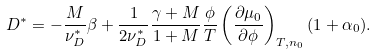Convert formula to latex. <formula><loc_0><loc_0><loc_500><loc_500>D ^ { * } = - \frac { M } { \nu _ { D } ^ { * } } \beta + \frac { 1 } { 2 \nu _ { D } ^ { * } } \frac { \gamma + M } { 1 + M } \frac { \phi } { T } \left ( \frac { \partial \mu _ { 0 } } { \partial \phi } \right ) _ { T , n _ { 0 } } ( 1 + \alpha _ { 0 } ) .</formula> 